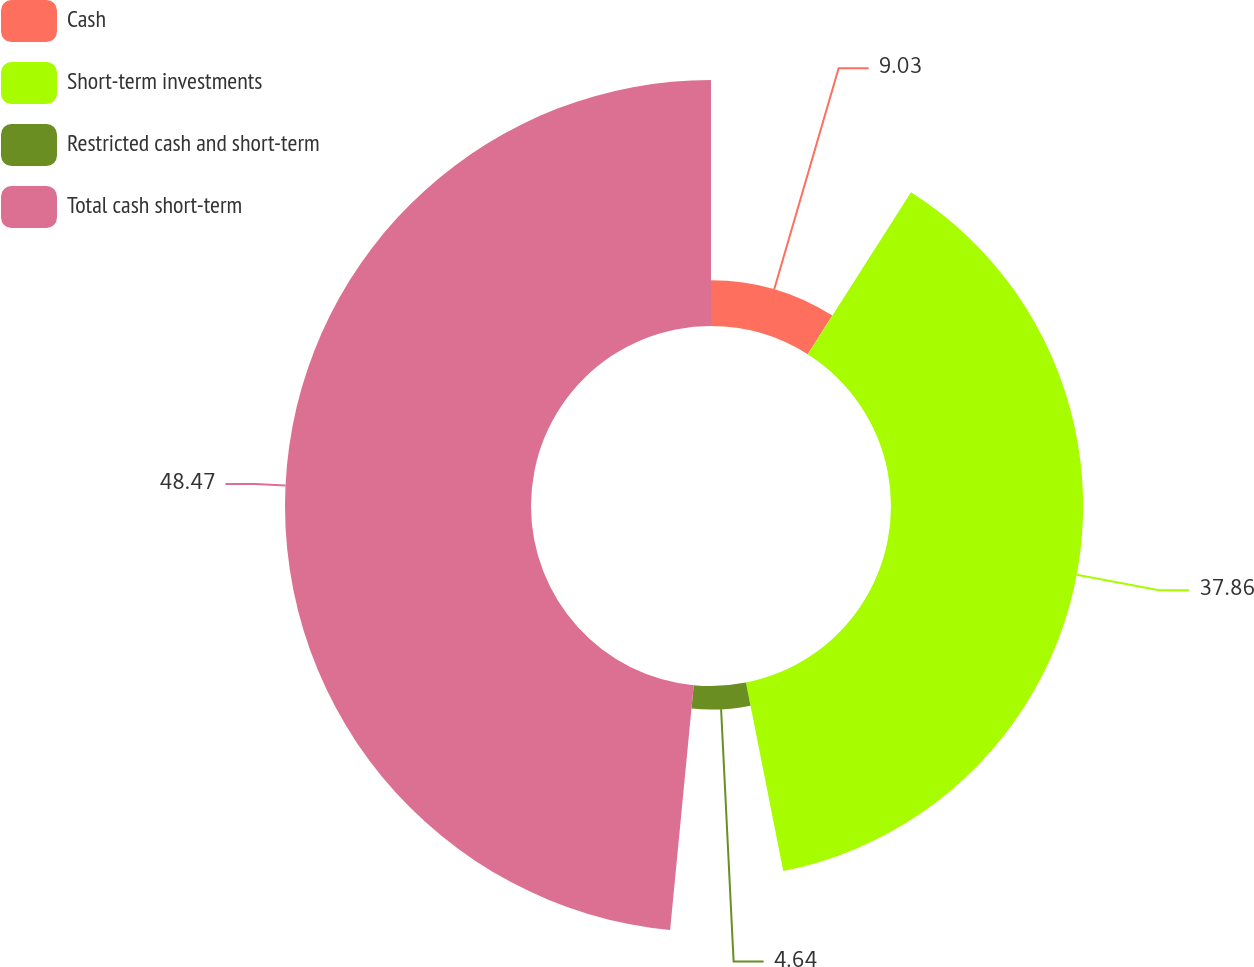Convert chart to OTSL. <chart><loc_0><loc_0><loc_500><loc_500><pie_chart><fcel>Cash<fcel>Short-term investments<fcel>Restricted cash and short-term<fcel>Total cash short-term<nl><fcel>9.03%<fcel>37.86%<fcel>4.64%<fcel>48.47%<nl></chart> 